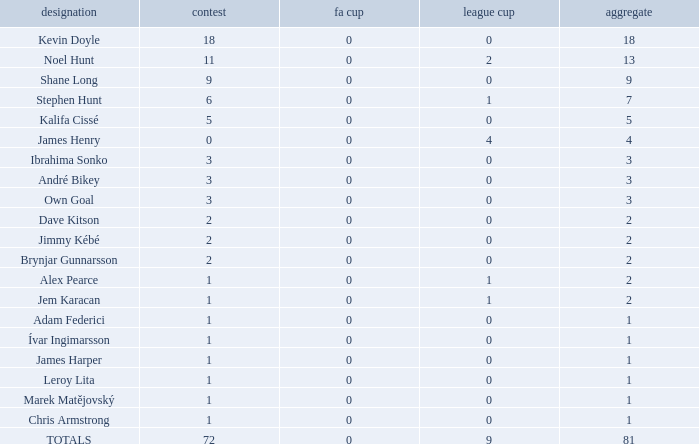What is the total championships of James Henry that has a league cup more than 1? 0.0. 